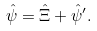Convert formula to latex. <formula><loc_0><loc_0><loc_500><loc_500>\hat { \psi } = \hat { \Xi } + \hat { \psi } ^ { \prime } .</formula> 